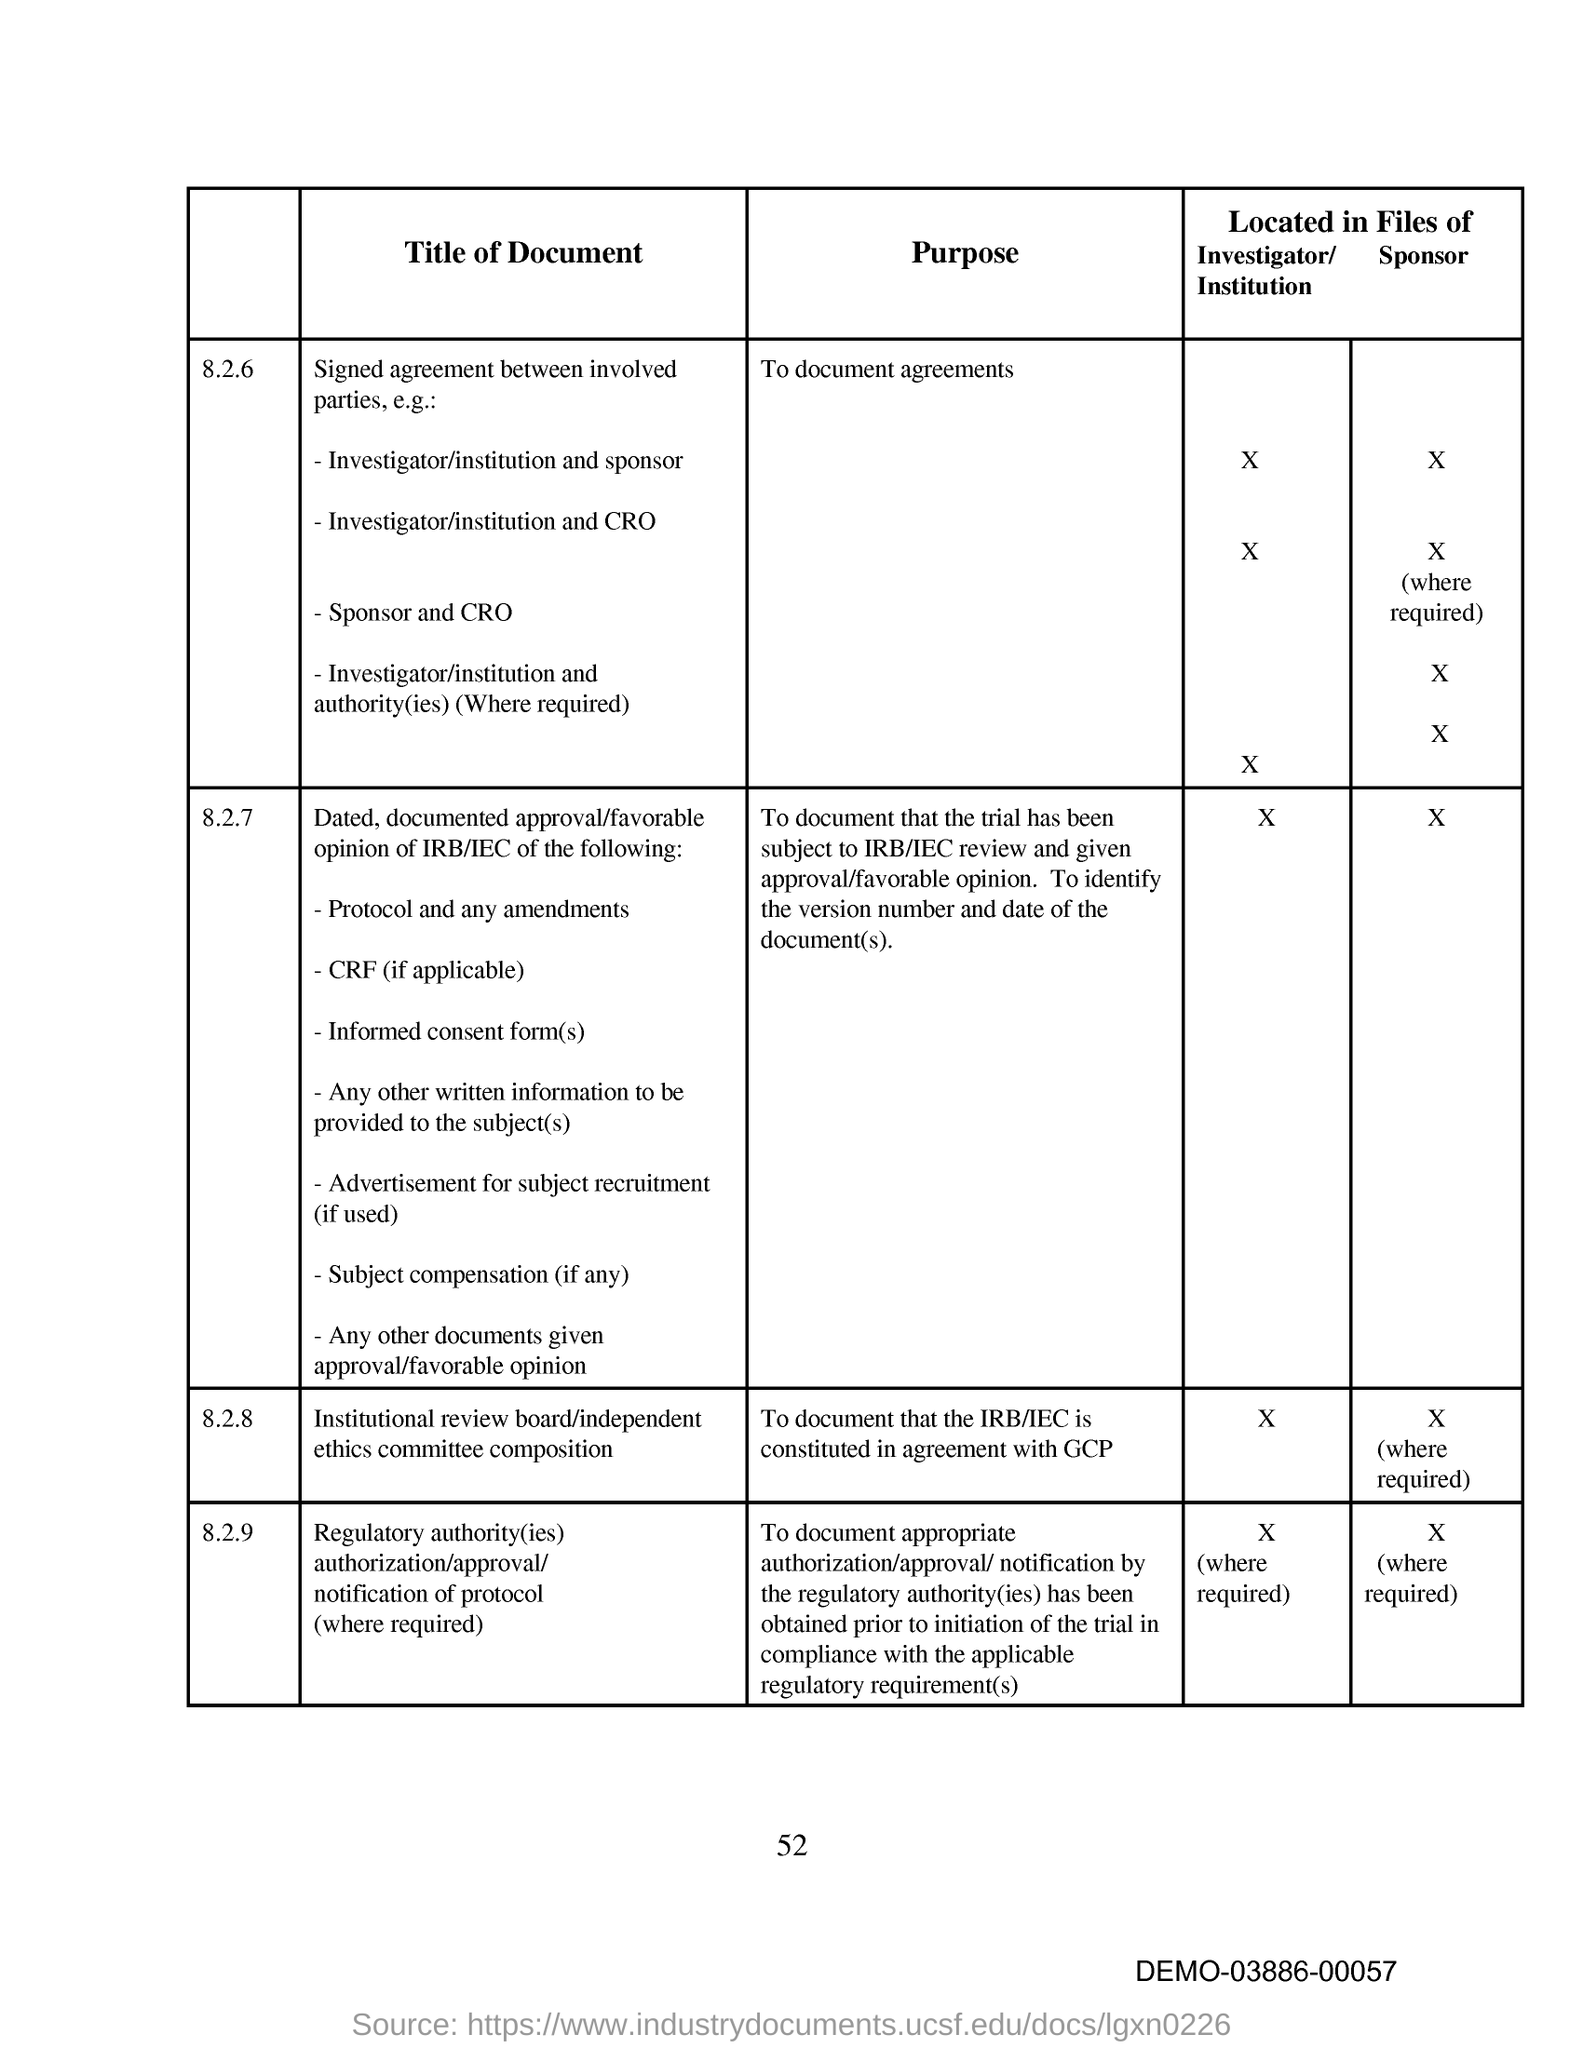What is the purpose of the document under 8.2.6?
Keep it short and to the point. To document agreements. What is the title of the document under 8.2.8?
Make the answer very short. Institutional review board/independent ethics committee composition. What is the page number on this document?
Your answer should be very brief. 52. 